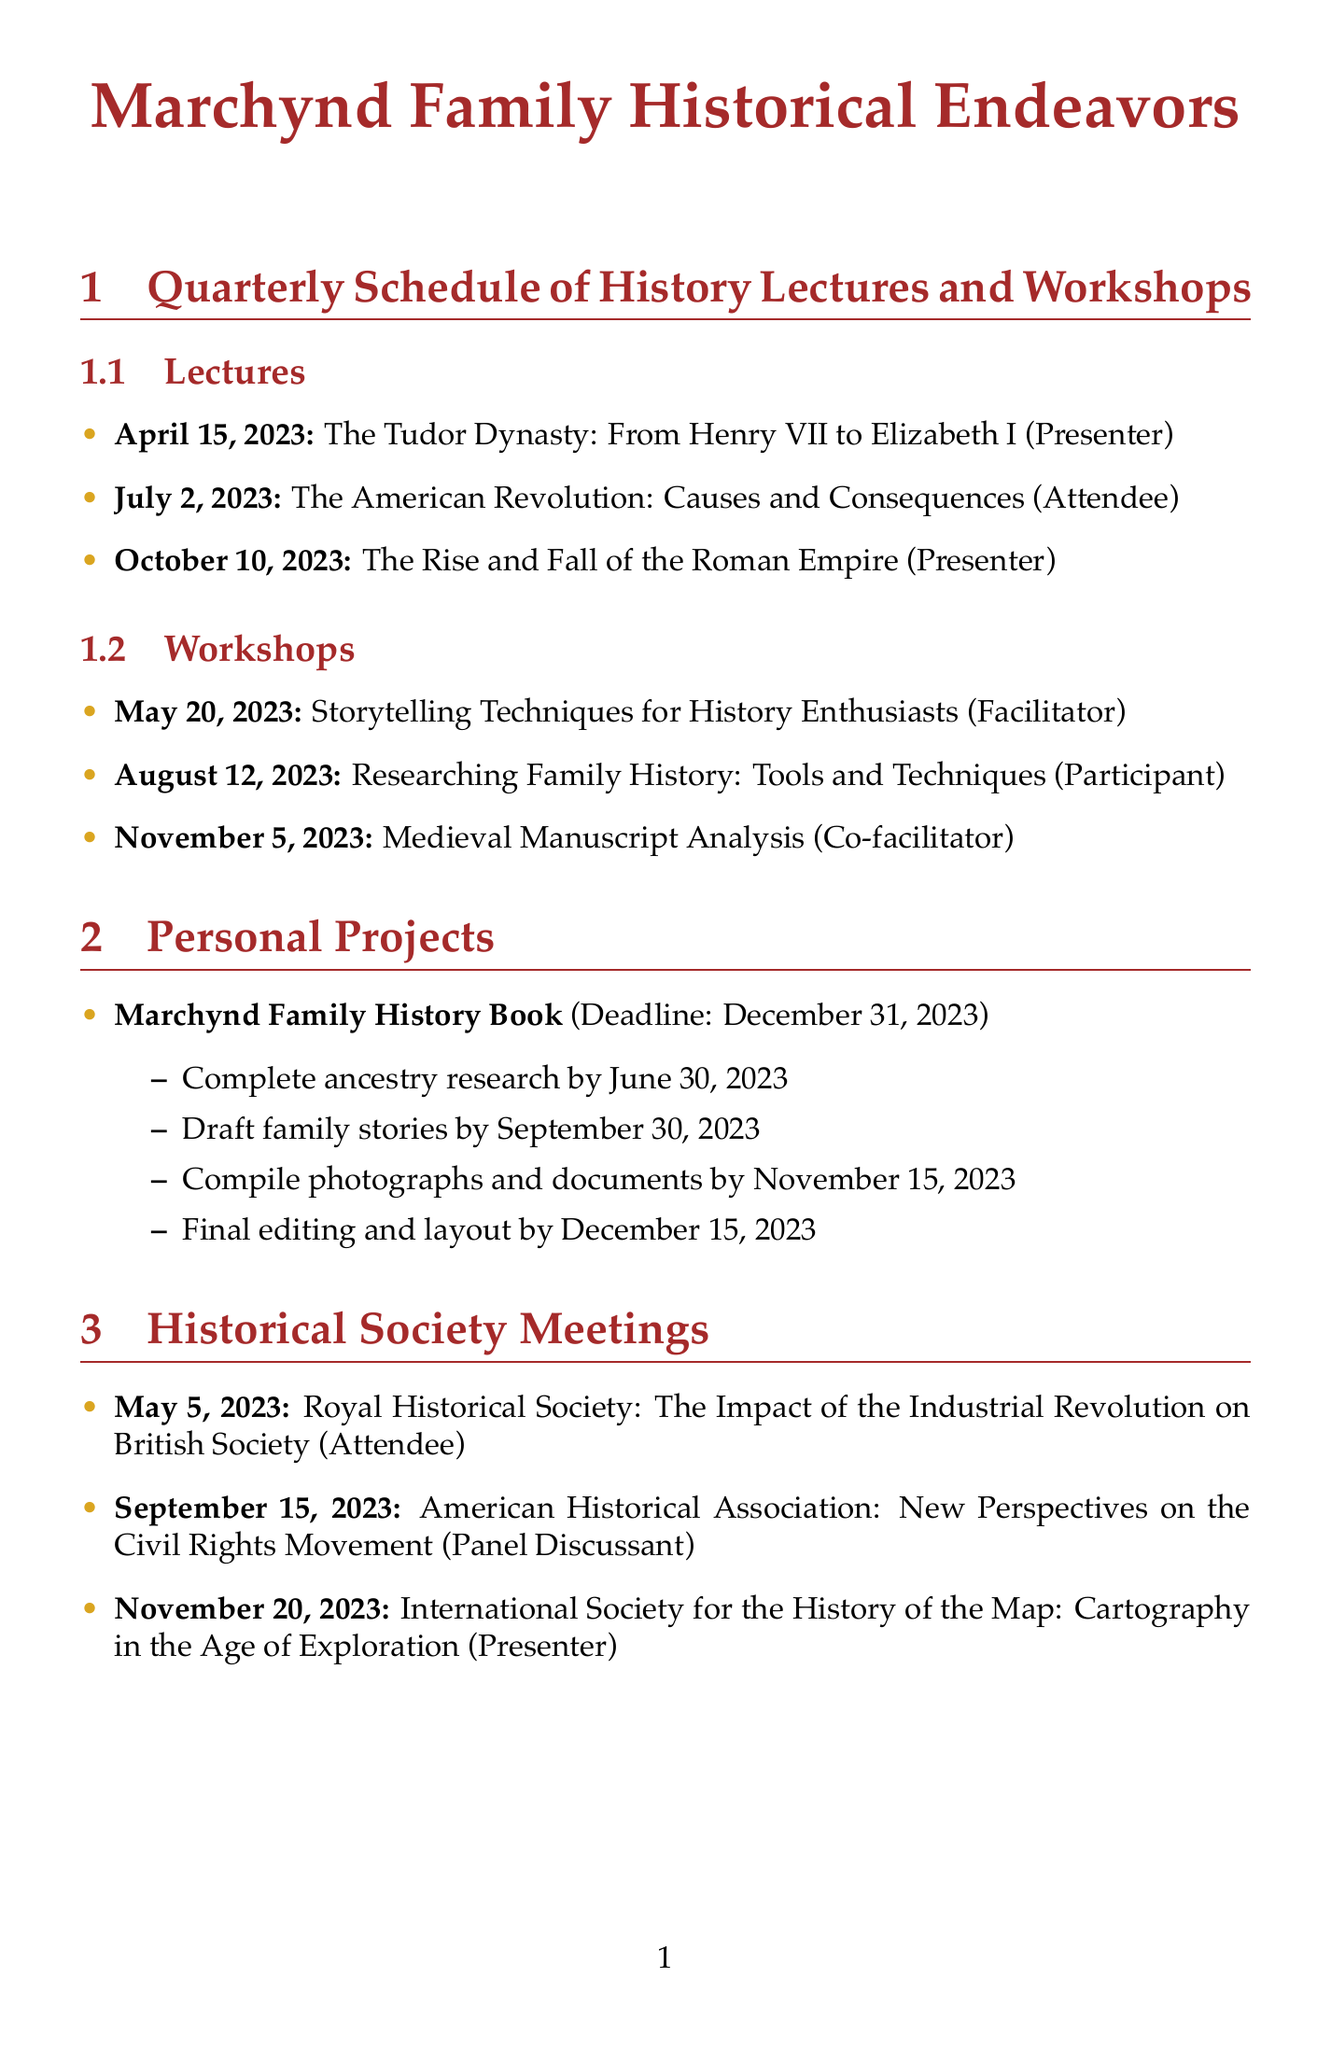What is the date of the lecture on the Tudor Dynasty? The date of the lecture is specifically mentioned in the document.
Answer: April 15, 2023 Who is the facilitator for the workshop on Storytelling Techniques? The document lists the roles for each workshop, including facilitators.
Answer: Facilitator What is the venue for the workshop on Researching Family History? The document identifies the venue for each workshop.
Answer: National Archives, Washington D.C When is the dress rehearsal for the Roman Empire lecture? The document outlines the preparation timelines, including dress rehearsals for each lecture.
Answer: October 5, 2023 How many milestones are listed for the Marchynd Family History Book? The document outlines the milestones related to the personal project.
Answer: Four What is the topic discussed in the Royal Historical Society meeting? The document specifies the topics of each historical society meeting.
Answer: The Impact of the Industrial Revolution on British Society What is the preparation timeline period for the workshop on Medieval Manuscript Analysis? The document includes comprehensive timelines for preparation, which can be assessed for the specific workshop.
Answer: September 30 to November 3, 2023 Which role will the participant have in the Historical Society meeting on September 15? The document mentions the roles for each historical society meeting, including titles.
Answer: Panel Discussant 